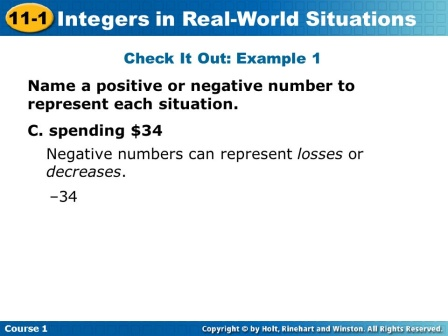If you were to visualize this concept in a different medium, like a short story, how would you do it? In a short story, I would visualize this concept through a character's experiences. Here's a brief outline:

Title: **Amanda's Day of Numbers**

Amanda, a curious young girl, decided to keep track of her day using numbers. She started her morning by finding $10 on her nightstand (-1; for the dollar bill she spent on lemonade). For lunch, she spent $7 on pasta (-7; more negative for the spending). She then won a small contest and earned $20 (+20; representing a gain). By evening, Amanda gave $15 to a friend as a gift (-15; representing a loss). Through her adventures, Amanda learns that positive numbers show what she gains and negative numbers represent her expenditures and losses. The story concludes with Amanda applying these principles to her savings, efficiently managing her finances using integers to signify her day-to-day transactions. Can you come up with a very creative question related to this image that goes beyond math concepts? Imagine if each number on this slide was a portal to a different universe. Describe what kind of world would exist behind the portal labeled 'negative 34'. Behind the portal labeled '-34', there exists a universe where everything is inversely proportional to our world. Here, spending money actually increases wealth in a whimsical twist of fate. Inhabitants thrive in an economy built upon giving rather than accumulating. The land is a fantastical place where every loss magically translates into a gain, leading to a society that flourishes on generosity and selflessness. The world thrives with innovations, as resources are limitless due to the unique economic principle. Imagine the excitement and the flourishing civilization that profits from kindness and sharing! 